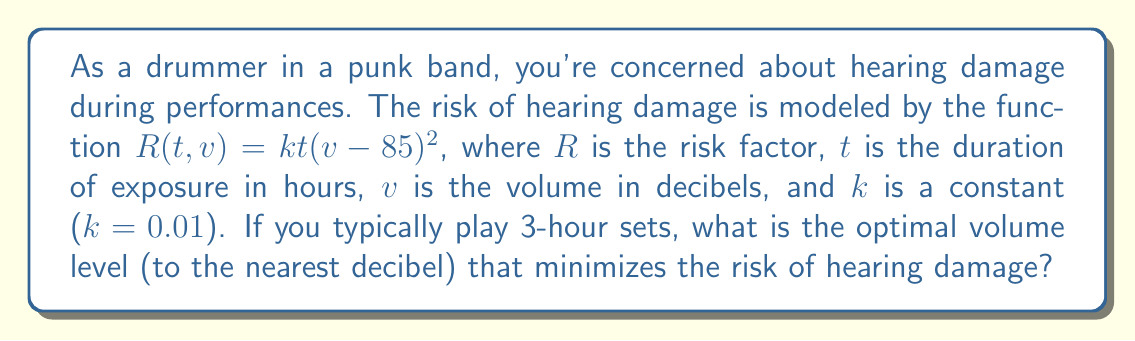Give your solution to this math problem. 1) The risk function is given by $R(t, v) = kt(v-85)^2$, where $t = 3$ hours for a typical set.

2) Substituting $t = 3$ and $k = 0.01$, we get:
   $R(v) = 0.03(v-85)^2$

3) To find the minimum risk, we need to find where the derivative of $R(v)$ equals zero:
   $\frac{dR}{dv} = 0.03 \cdot 2(v-85) = 0.06(v-85)$

4) Setting this equal to zero:
   $0.06(v-85) = 0$
   $v-85 = 0$
   $v = 85$

5) The second derivative is positive ($\frac{d^2R}{dv^2} = 0.06 > 0$), confirming this is a minimum.

6) Therefore, the optimal volume level that minimizes hearing damage risk is 85 decibels.
Answer: 85 dB 